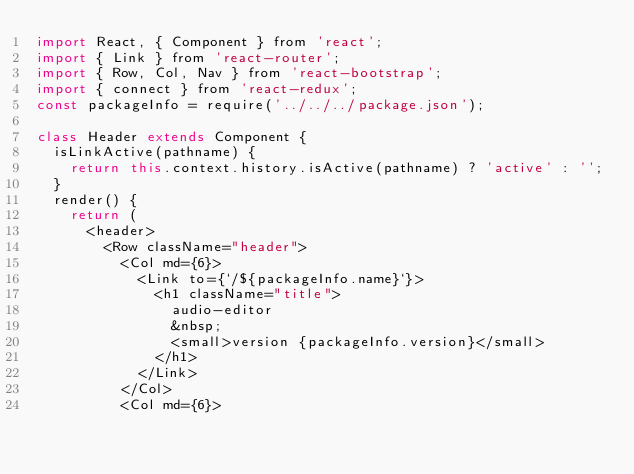<code> <loc_0><loc_0><loc_500><loc_500><_JavaScript_>import React, { Component } from 'react';
import { Link } from 'react-router';
import { Row, Col, Nav } from 'react-bootstrap';
import { connect } from 'react-redux';
const packageInfo = require('../../../package.json');

class Header extends Component {
	isLinkActive(pathname) {
		return this.context.history.isActive(pathname) ? 'active' : '';
	}
	render() {
		return (
			<header>
				<Row className="header">
					<Col md={6}>
						<Link to={`/${packageInfo.name}`}>
							<h1 className="title">
								audio-editor
								&nbsp;
								<small>version {packageInfo.version}</small>
							</h1>
						</Link>
					</Col>
					<Col md={6}></code> 